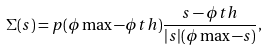<formula> <loc_0><loc_0><loc_500><loc_500>\Sigma ( s ) = p ( \phi \max - \phi t h ) \frac { s - \phi t h } { | s | ( \phi \max - s ) } ,</formula> 